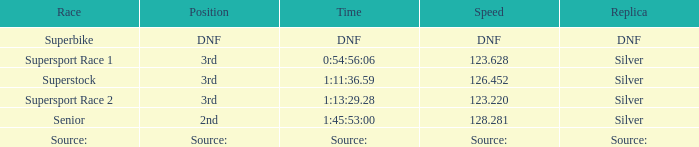Which race has a placement of 3rd and a speed of 12 Supersport Race 1. 